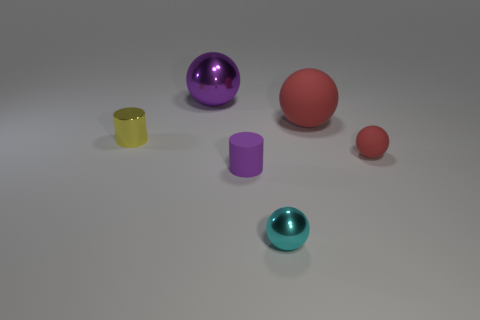Subtract all brown cubes. How many red spheres are left? 2 Add 2 big brown metal balls. How many objects exist? 8 Subtract all gray balls. Subtract all red cubes. How many balls are left? 4 Subtract all large green cylinders. Subtract all purple rubber things. How many objects are left? 5 Add 3 tiny yellow shiny objects. How many tiny yellow shiny objects are left? 4 Add 4 red matte spheres. How many red matte spheres exist? 6 Subtract 0 brown cylinders. How many objects are left? 6 Subtract all cylinders. How many objects are left? 4 